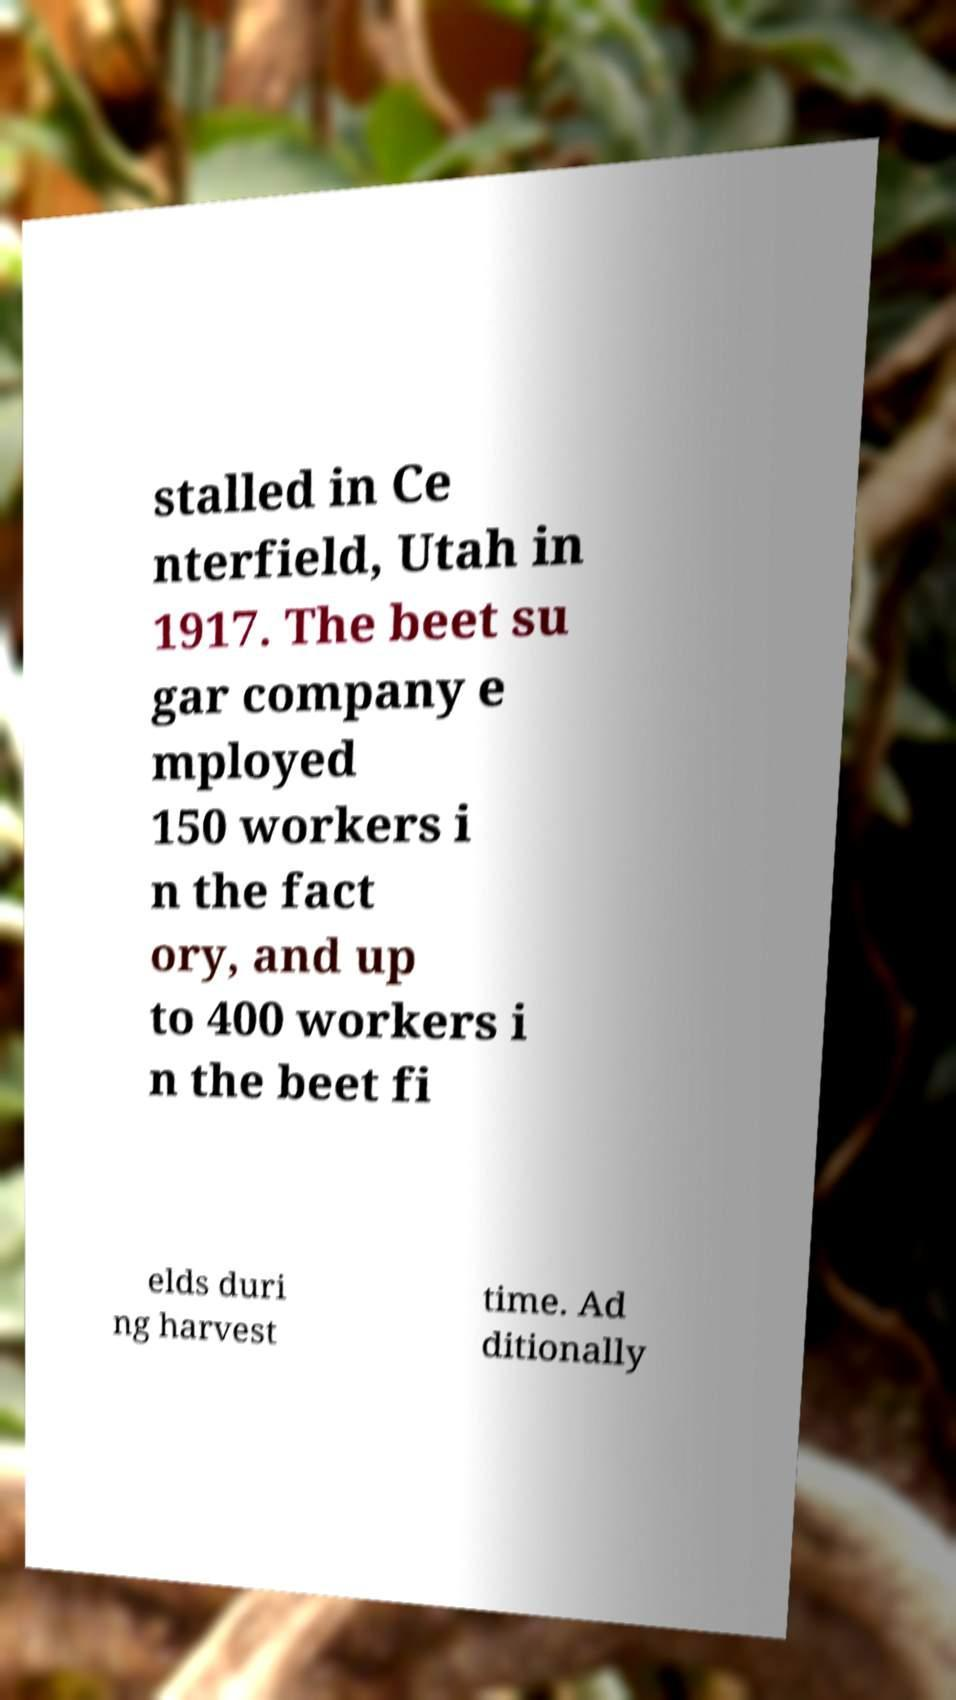There's text embedded in this image that I need extracted. Can you transcribe it verbatim? stalled in Ce nterfield, Utah in 1917. The beet su gar company e mployed 150 workers i n the fact ory, and up to 400 workers i n the beet fi elds duri ng harvest time. Ad ditionally 